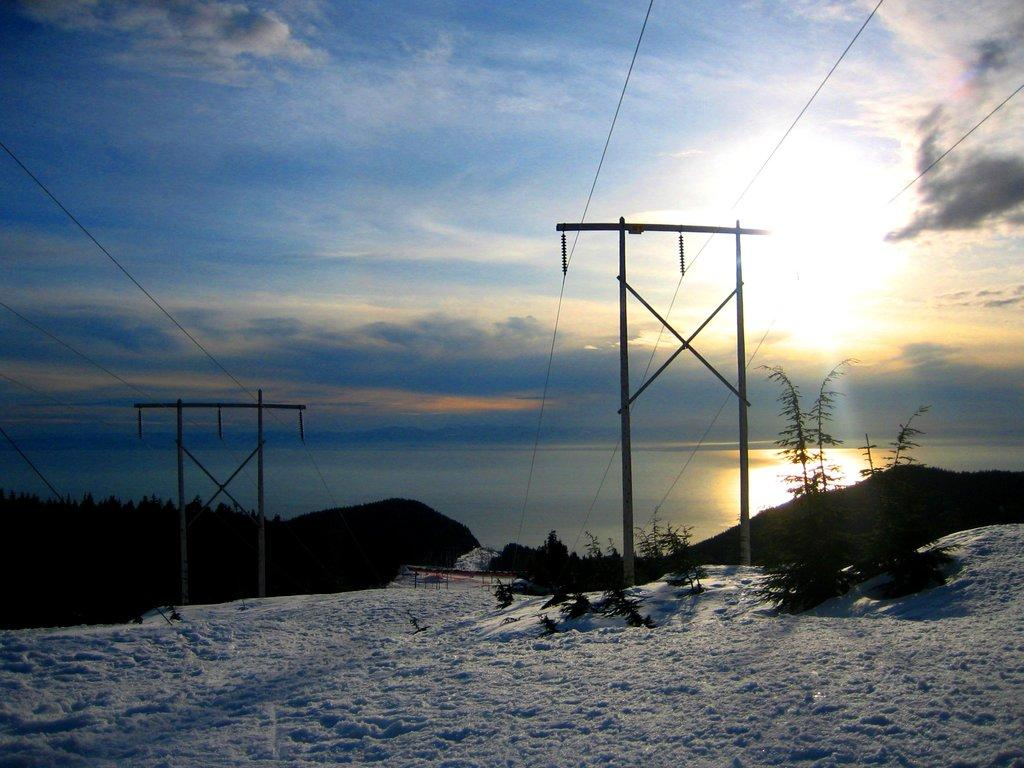What structures can be seen on the ground in the image? There are electric poles on the ground in the image. What is covering the ground in the image? There is snow on the ground in the image. What can be seen in the background of the image? There are mountains and trees in the background of the image. What is visible at the top of the image? The sky is visible at the top of the image. Can you see a balloon floating in the sky in the image? There is no balloon visible in the sky in the image. What type of sock is being worn by the mountain in the background? There are no socks present in the image, as mountains do not wear clothing. 